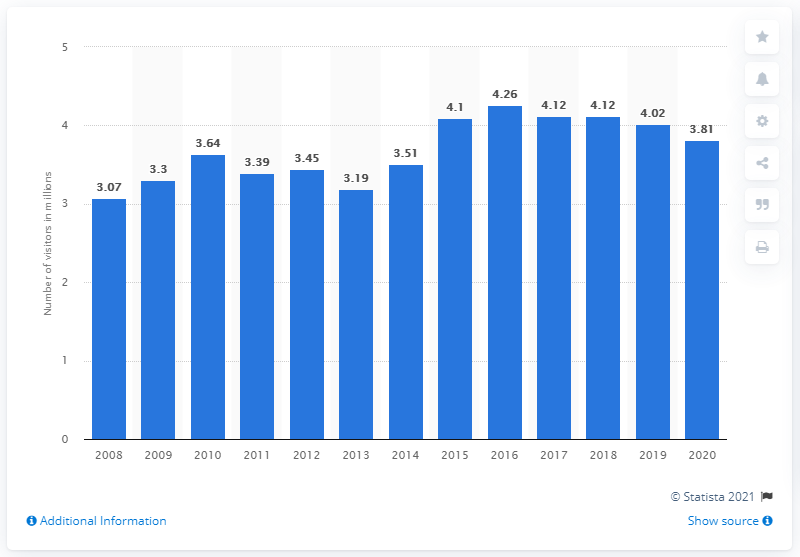Give some essential details in this illustration. In the previous year, the total number of visitors to Yellowstone National Park was 4,020,000. Since 2008, Yellowstone National Park has received an average of 4.02 million visitors annually. In 2020, Yellowstone attracted a total of 3.81 million visitors. 